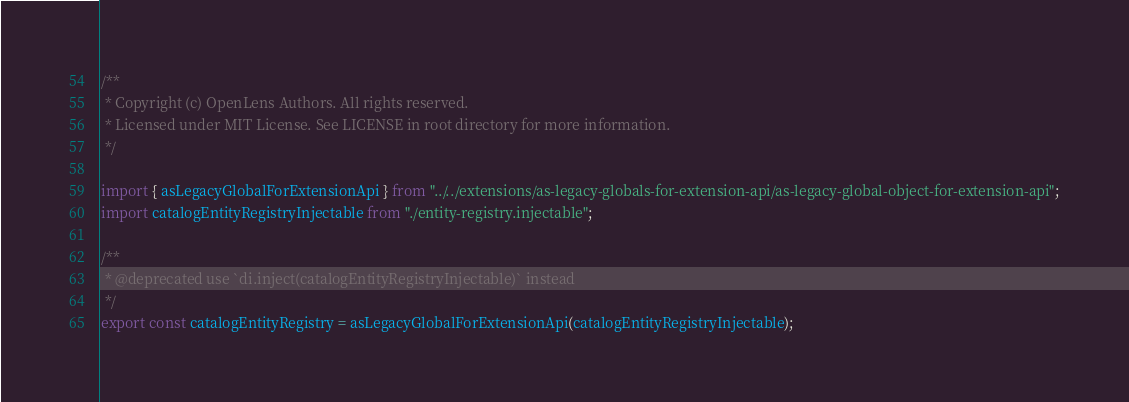<code> <loc_0><loc_0><loc_500><loc_500><_TypeScript_>/**
 * Copyright (c) OpenLens Authors. All rights reserved.
 * Licensed under MIT License. See LICENSE in root directory for more information.
 */

import { asLegacyGlobalForExtensionApi } from "../../extensions/as-legacy-globals-for-extension-api/as-legacy-global-object-for-extension-api";
import catalogEntityRegistryInjectable from "./entity-registry.injectable";

/**
 * @deprecated use `di.inject(catalogEntityRegistryInjectable)` instead
 */
export const catalogEntityRegistry = asLegacyGlobalForExtensionApi(catalogEntityRegistryInjectable);
</code> 